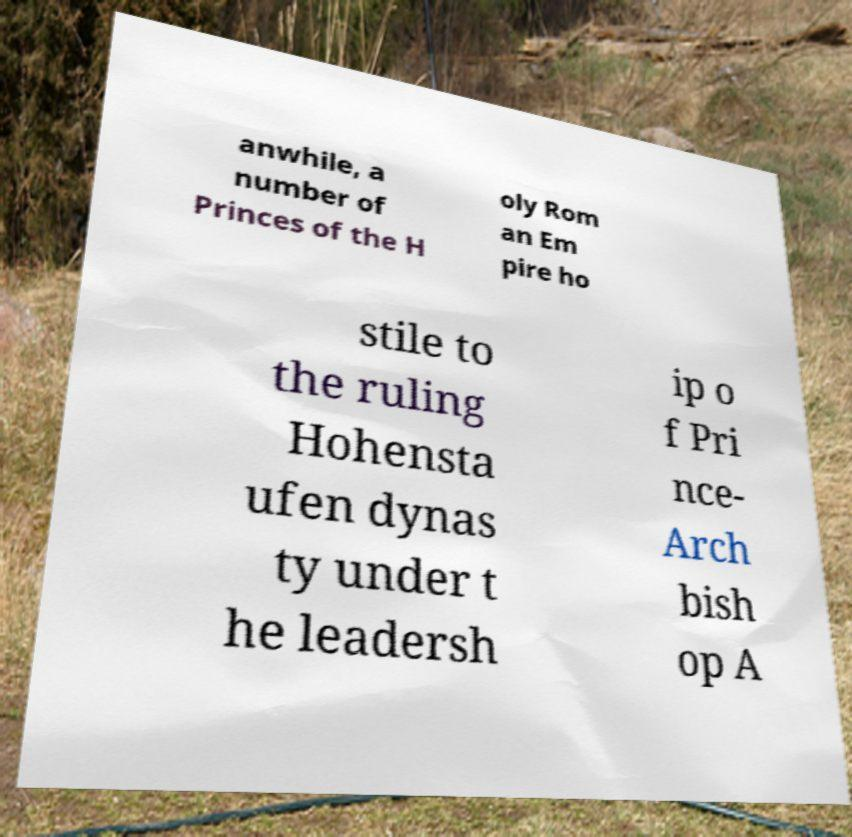Could you assist in decoding the text presented in this image and type it out clearly? anwhile, a number of Princes of the H oly Rom an Em pire ho stile to the ruling Hohensta ufen dynas ty under t he leadersh ip o f Pri nce- Arch bish op A 